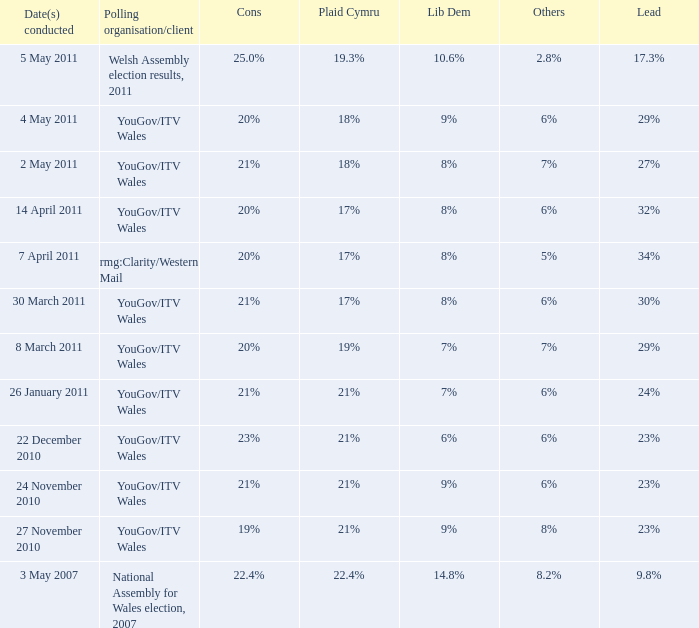Provide the dates undertaken for plaid cymru consisting of 19%. 8 March 2011. 